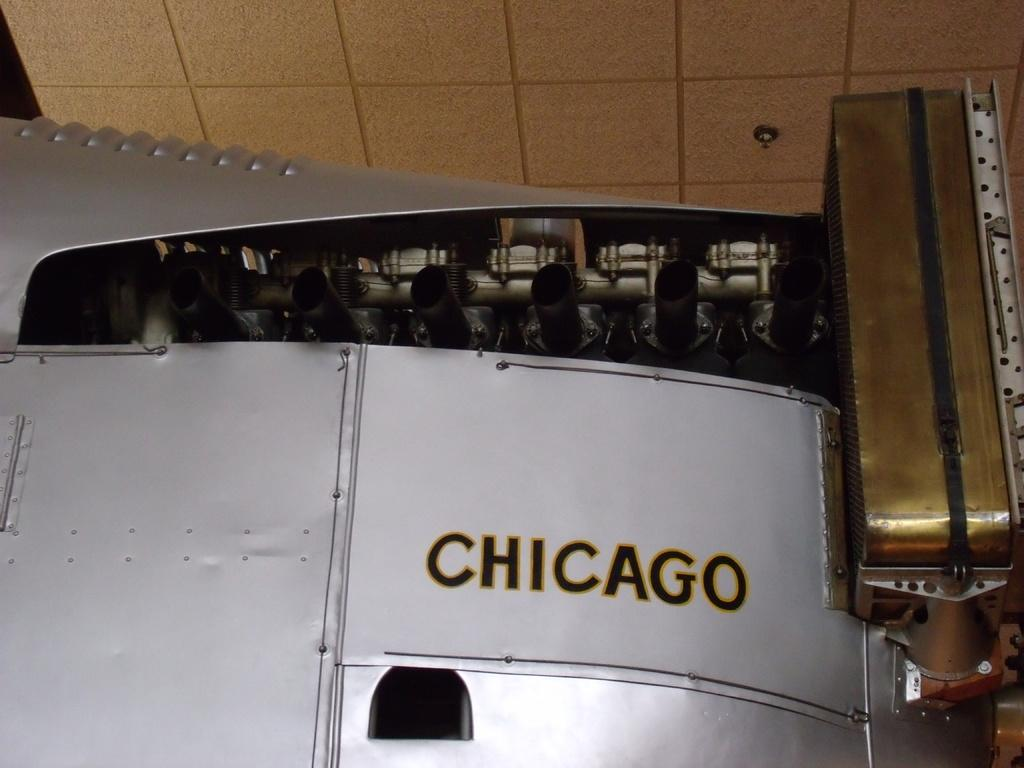<image>
Share a concise interpretation of the image provided. A large imposing airplane has the name CHICAGO on its side. 